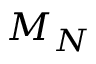<formula> <loc_0><loc_0><loc_500><loc_500>M _ { N }</formula> 